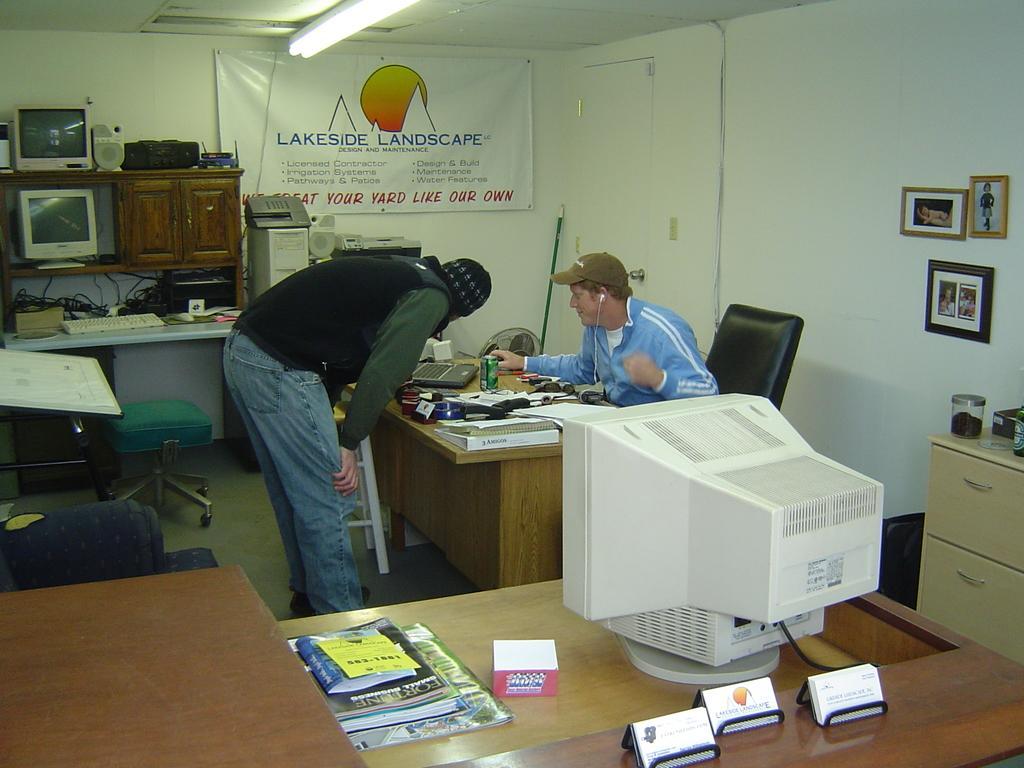Describe this image in one or two sentences. In the image we can see there is a man who is sitting on chair and another man is standing on the table we can see there are papers, laptop, can. 